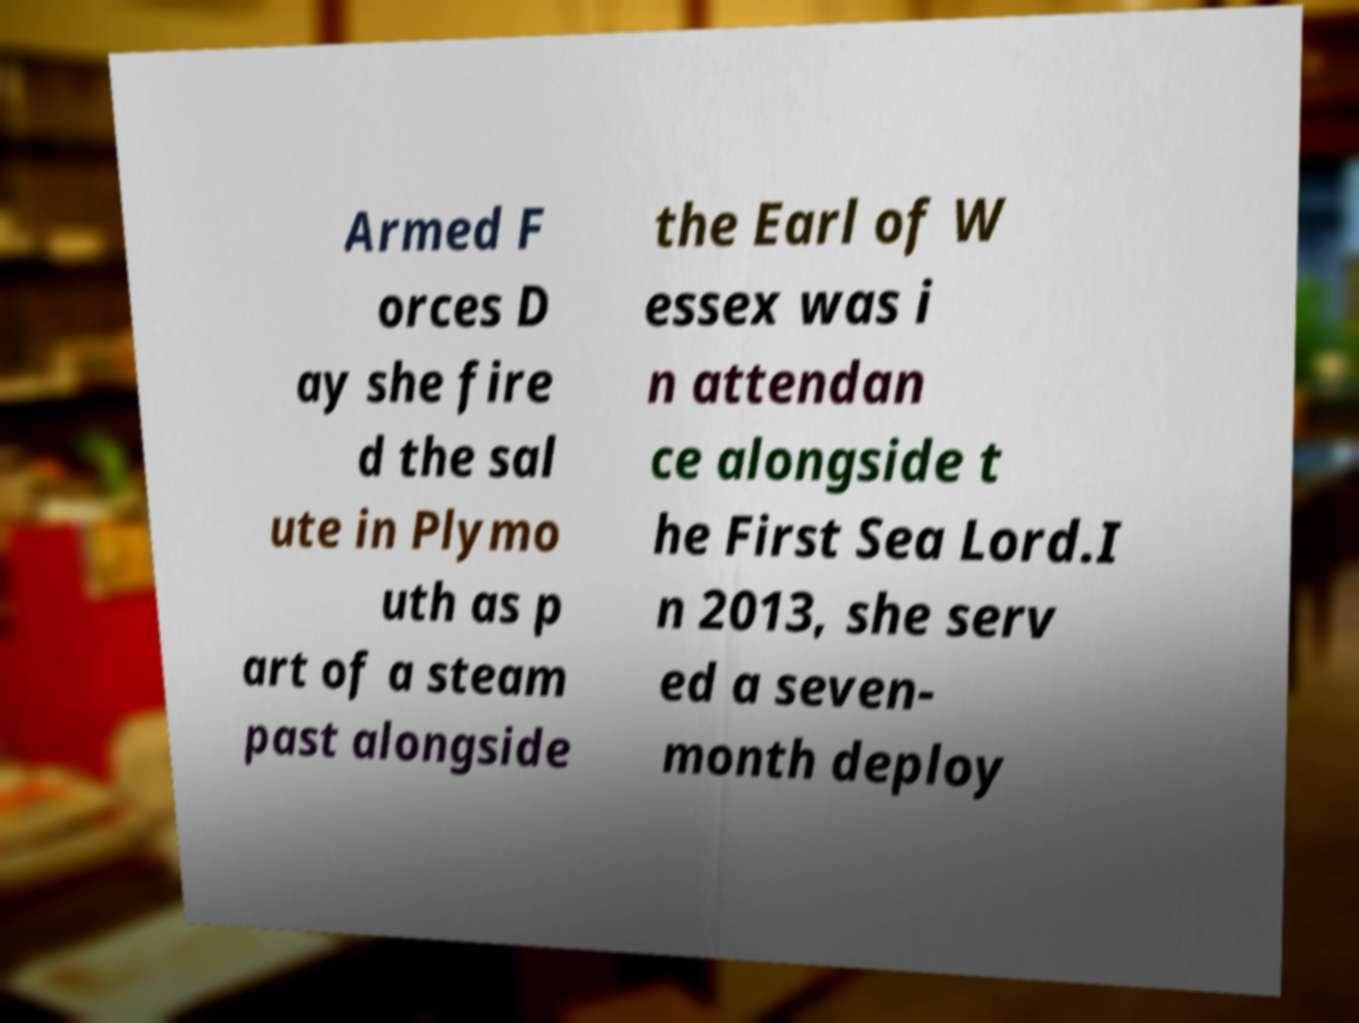Can you accurately transcribe the text from the provided image for me? Armed F orces D ay she fire d the sal ute in Plymo uth as p art of a steam past alongside the Earl of W essex was i n attendan ce alongside t he First Sea Lord.I n 2013, she serv ed a seven- month deploy 